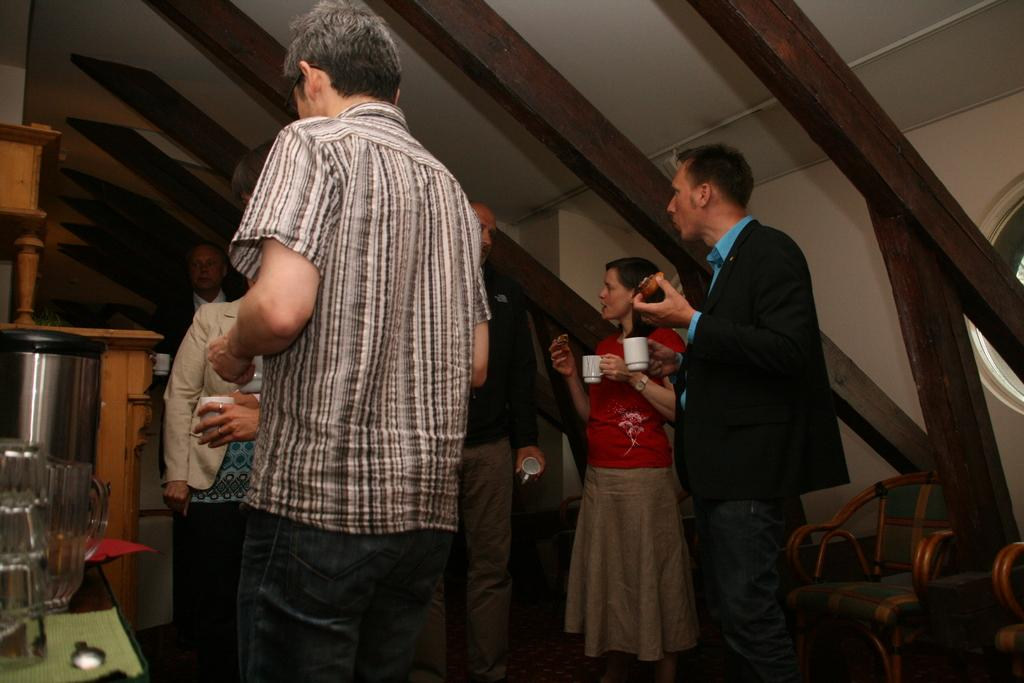Who or what is present in the image? There are persons in the image. What are the persons holding in their hands? The persons are holding cups. What can be seen on the left side of the image? There is a mug on the left side of the image. What piece of furniture is visible in the image? There is a table in the image. What is visible at the top of the image? There is a roof visible at the top of the image. What type of seating is on the right side of the image? There are chairs on the right side of the image. Can you tell me how many hands are visible in the image? There is no specific mention of hands in the image, so it is not possible to determine the number of hands visible. 